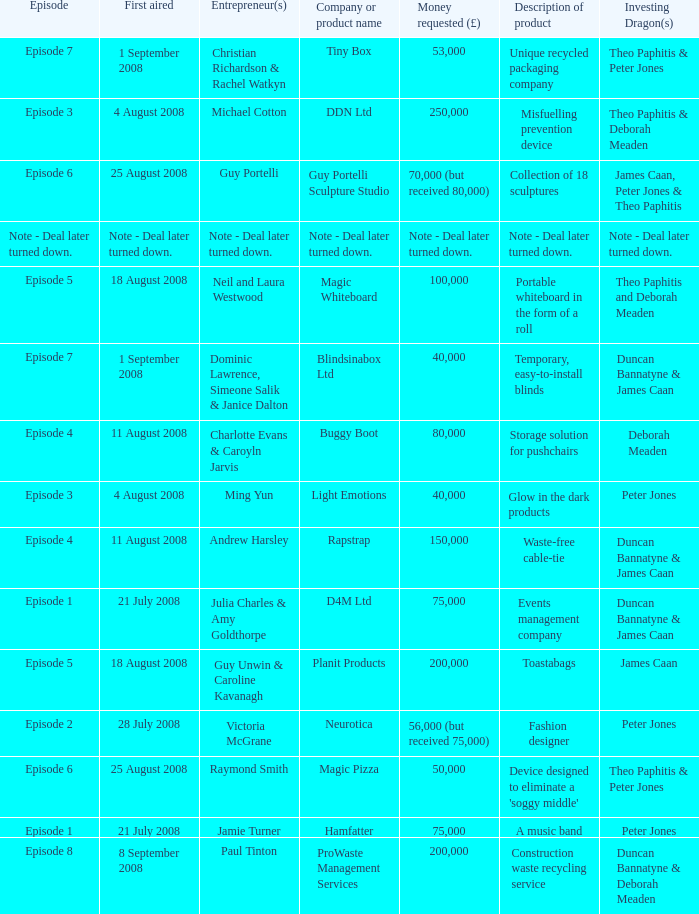When did episode 6 first air with entrepreneur Guy Portelli? 25 August 2008. 